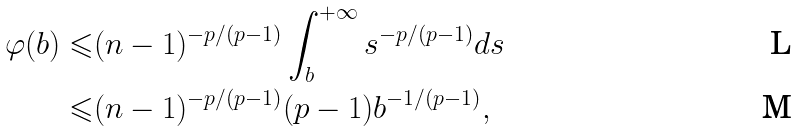<formula> <loc_0><loc_0><loc_500><loc_500>\varphi ( b ) \leqslant & ( n - 1 ) ^ { - p / ( p - 1 ) } \int _ { b } ^ { + \infty } s ^ { - p / ( p - 1 ) } d s \\ \leqslant & ( n - 1 ) ^ { - p / ( p - 1 ) } ( p - 1 ) b ^ { - 1 / ( p - 1 ) } ,</formula> 